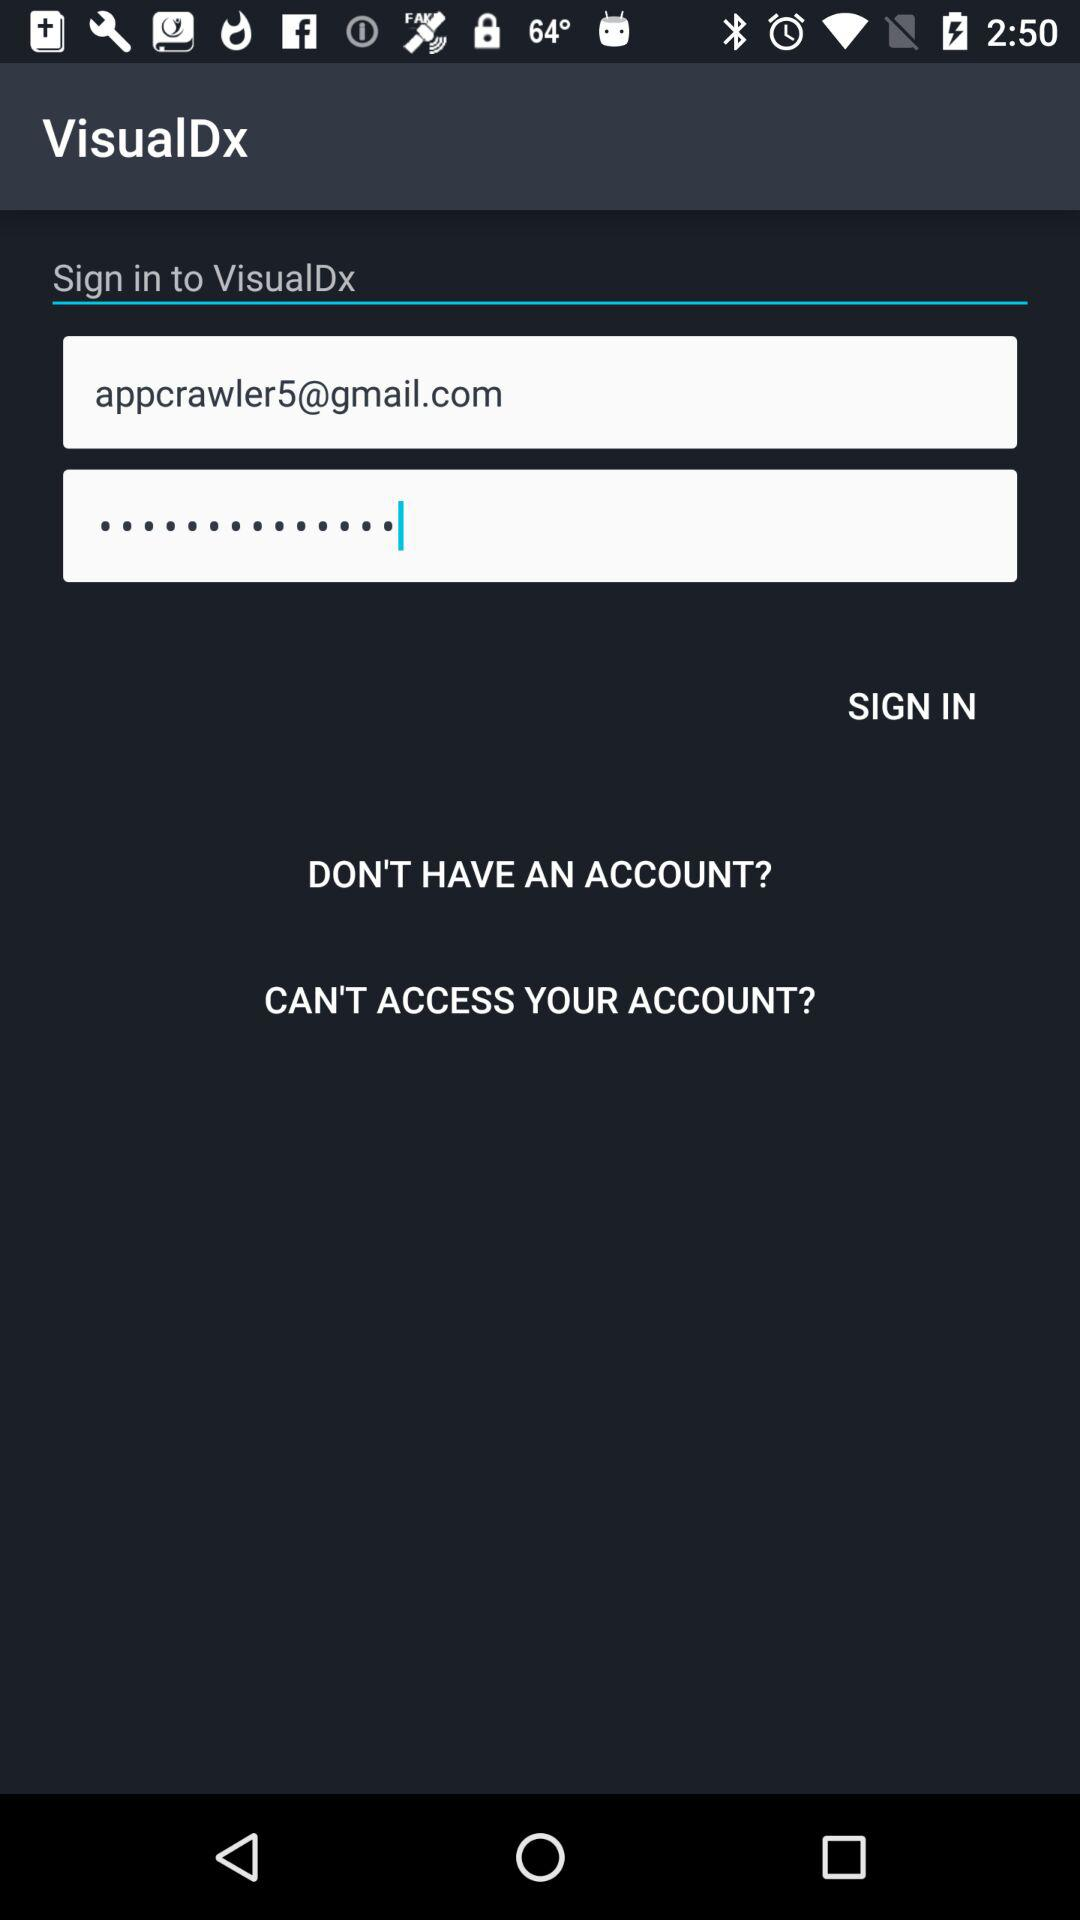What is the given email address? The given email address is appcrawler5@gmail.com. 